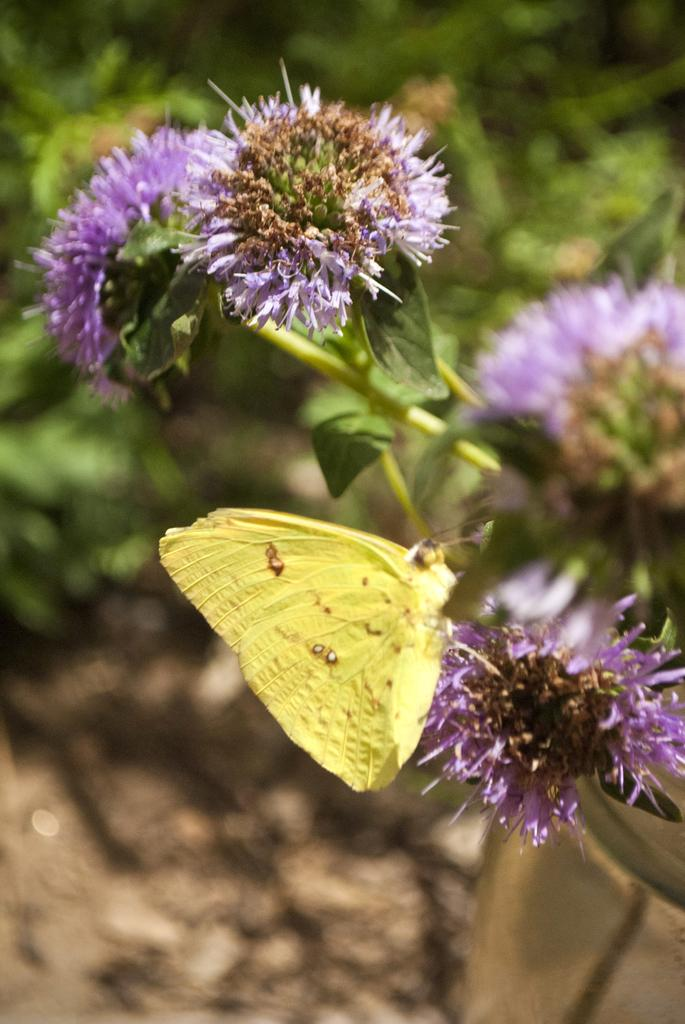What type of plant can be seen in the image? There is a flower plant in the image. What other living organism is present in the image? There is a butterfly in the image. Can you describe the background of the image? The background of the image includes a blurred view, with plants and the ground visible. How many babies are taking a bath in the image? There are no babies or baths present in the image. 